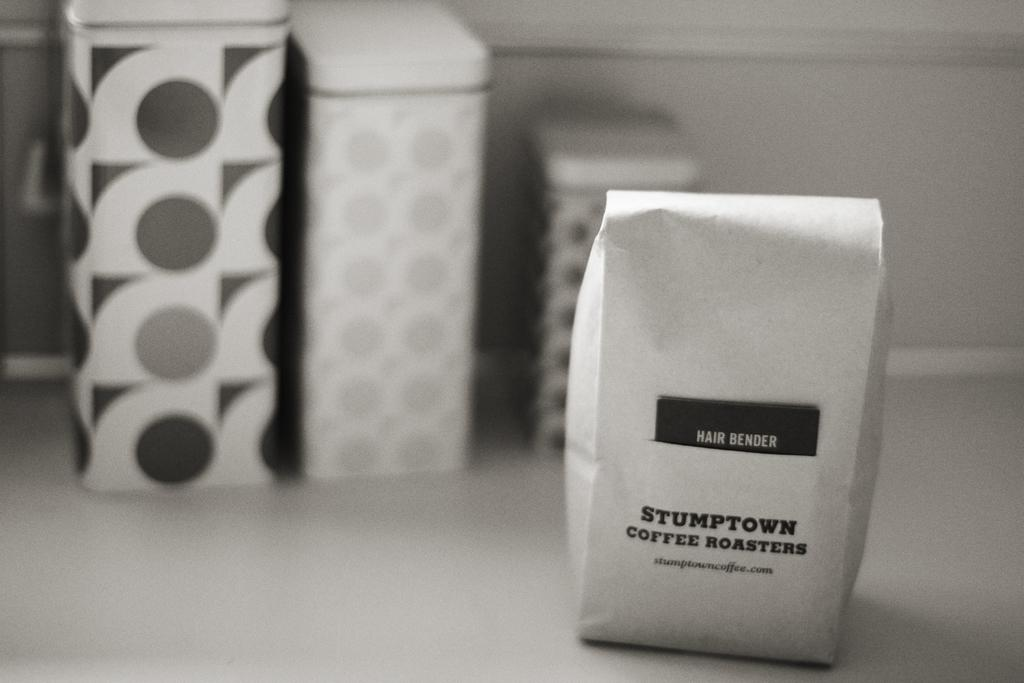<image>
Summarize the visual content of the image. a small cardboard square that has a label that says 'stumptown coffee roasters' on it 